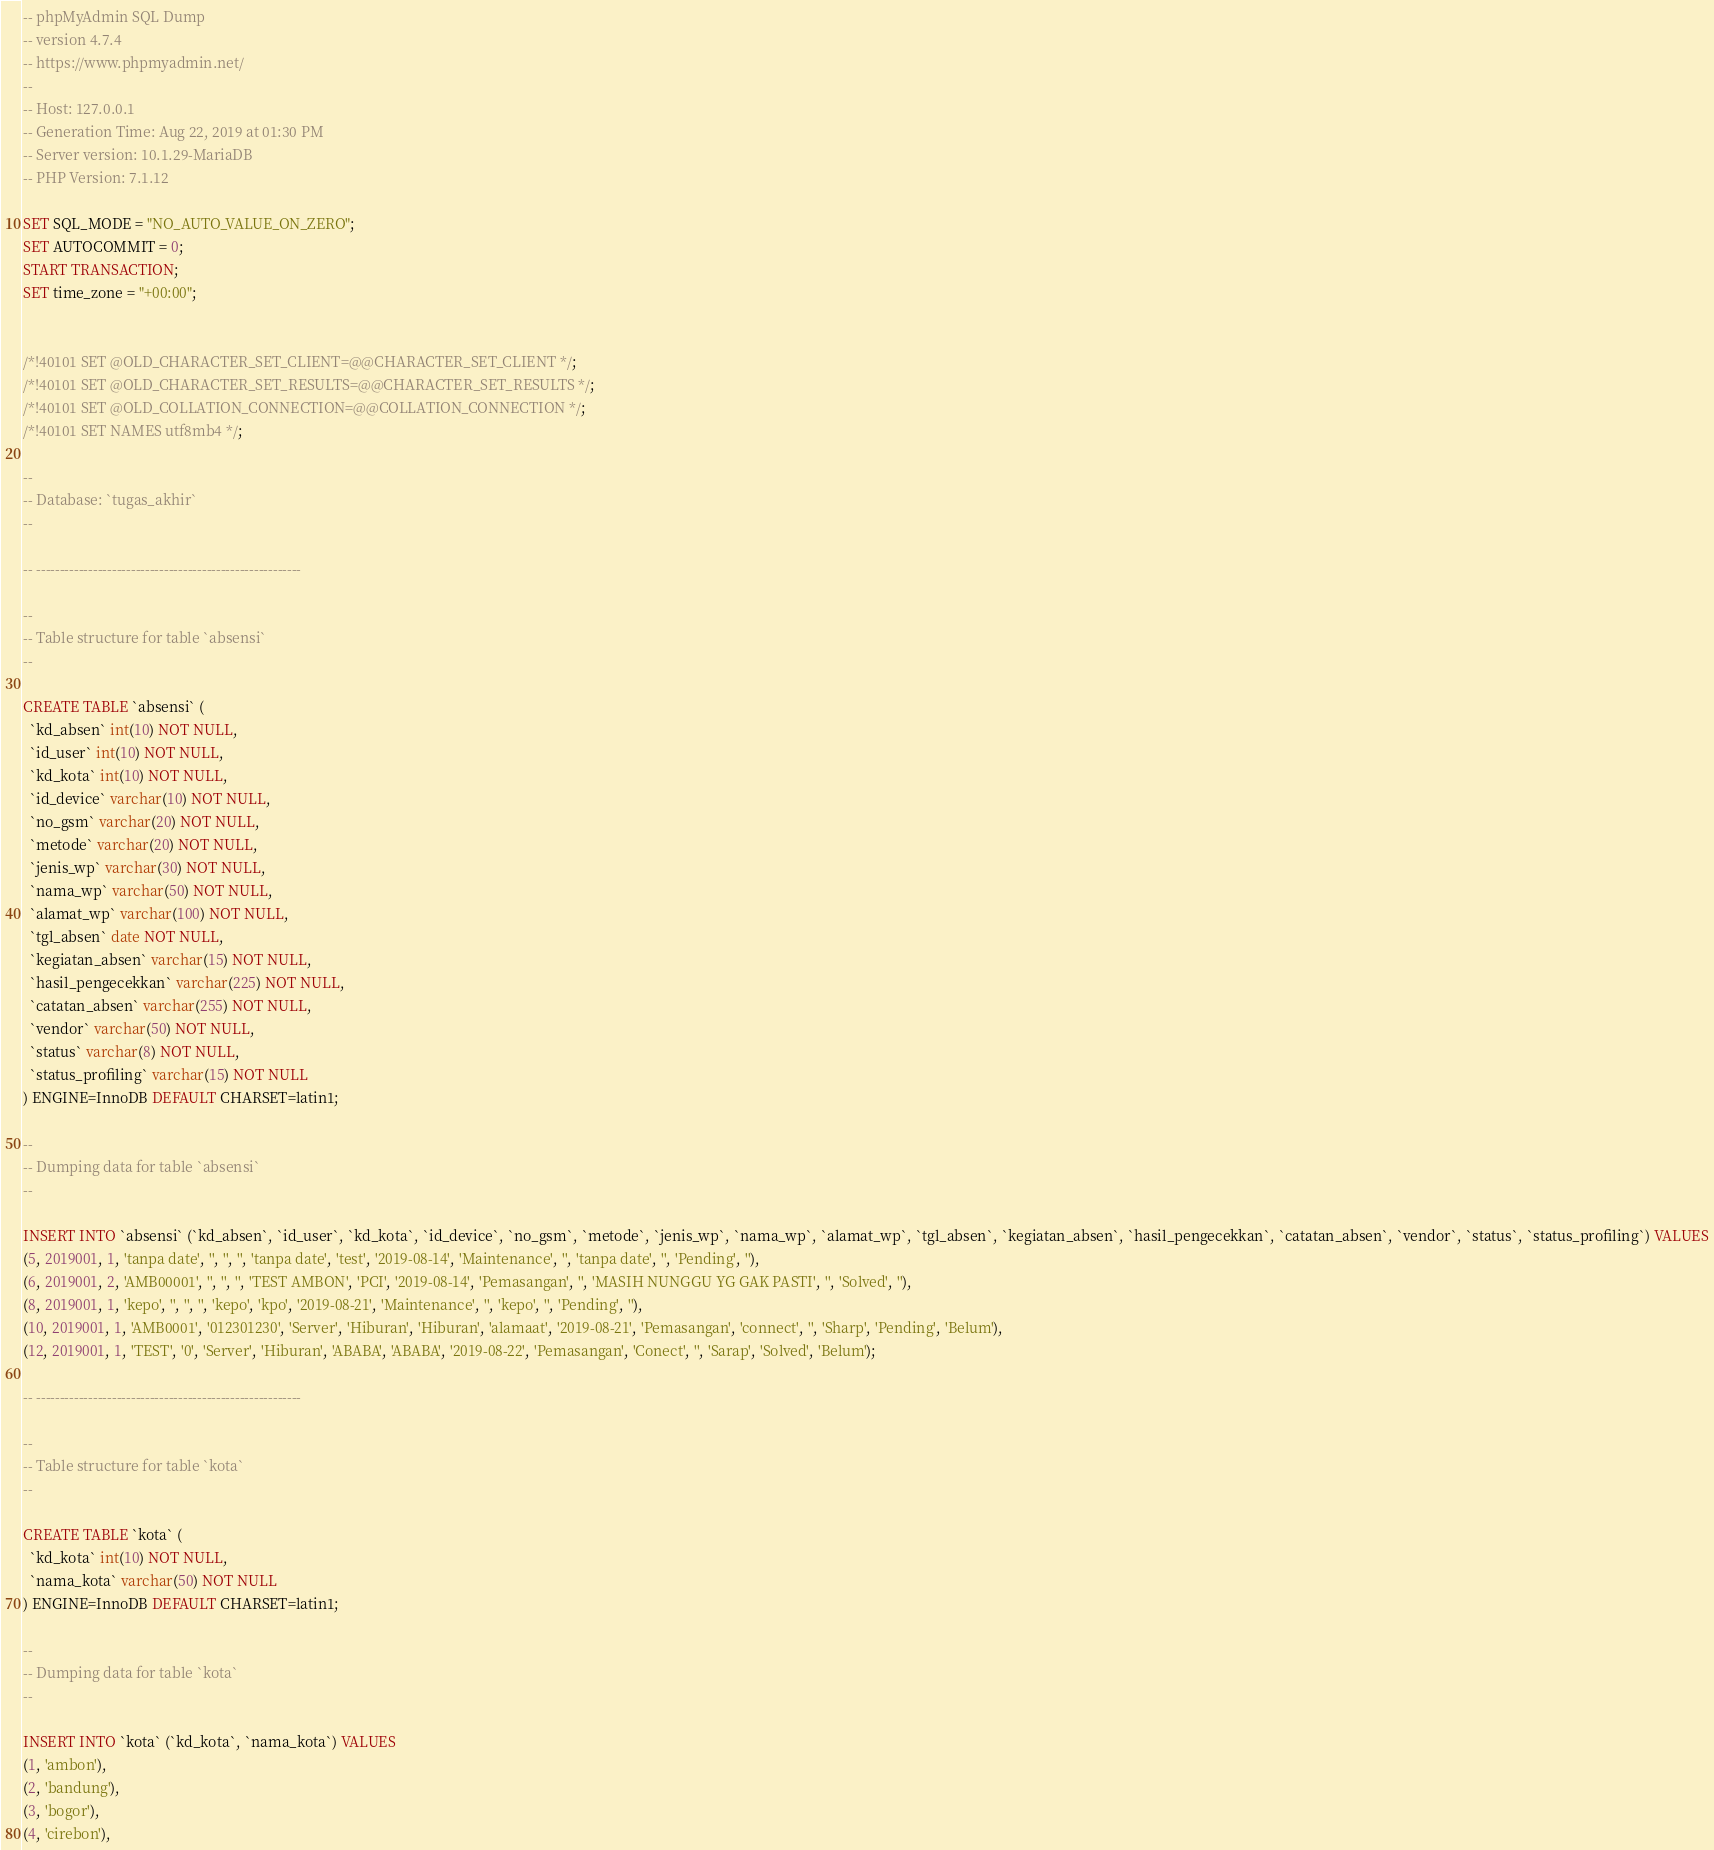<code> <loc_0><loc_0><loc_500><loc_500><_SQL_>-- phpMyAdmin SQL Dump
-- version 4.7.4
-- https://www.phpmyadmin.net/
--
-- Host: 127.0.0.1
-- Generation Time: Aug 22, 2019 at 01:30 PM
-- Server version: 10.1.29-MariaDB
-- PHP Version: 7.1.12

SET SQL_MODE = "NO_AUTO_VALUE_ON_ZERO";
SET AUTOCOMMIT = 0;
START TRANSACTION;
SET time_zone = "+00:00";


/*!40101 SET @OLD_CHARACTER_SET_CLIENT=@@CHARACTER_SET_CLIENT */;
/*!40101 SET @OLD_CHARACTER_SET_RESULTS=@@CHARACTER_SET_RESULTS */;
/*!40101 SET @OLD_COLLATION_CONNECTION=@@COLLATION_CONNECTION */;
/*!40101 SET NAMES utf8mb4 */;

--
-- Database: `tugas_akhir`
--

-- --------------------------------------------------------

--
-- Table structure for table `absensi`
--

CREATE TABLE `absensi` (
  `kd_absen` int(10) NOT NULL,
  `id_user` int(10) NOT NULL,
  `kd_kota` int(10) NOT NULL,
  `id_device` varchar(10) NOT NULL,
  `no_gsm` varchar(20) NOT NULL,
  `metode` varchar(20) NOT NULL,
  `jenis_wp` varchar(30) NOT NULL,
  `nama_wp` varchar(50) NOT NULL,
  `alamat_wp` varchar(100) NOT NULL,
  `tgl_absen` date NOT NULL,
  `kegiatan_absen` varchar(15) NOT NULL,
  `hasil_pengecekkan` varchar(225) NOT NULL,
  `catatan_absen` varchar(255) NOT NULL,
  `vendor` varchar(50) NOT NULL,
  `status` varchar(8) NOT NULL,
  `status_profiling` varchar(15) NOT NULL
) ENGINE=InnoDB DEFAULT CHARSET=latin1;

--
-- Dumping data for table `absensi`
--

INSERT INTO `absensi` (`kd_absen`, `id_user`, `kd_kota`, `id_device`, `no_gsm`, `metode`, `jenis_wp`, `nama_wp`, `alamat_wp`, `tgl_absen`, `kegiatan_absen`, `hasil_pengecekkan`, `catatan_absen`, `vendor`, `status`, `status_profiling`) VALUES
(5, 2019001, 1, 'tanpa date', '', '', '', 'tanpa date', 'test', '2019-08-14', 'Maintenance', '', 'tanpa date', '', 'Pending', ''),
(6, 2019001, 2, 'AMB00001', '', '', '', 'TEST AMBON', 'PCI', '2019-08-14', 'Pemasangan', '', 'MASIH NUNGGU YG GAK PASTI', '', 'Solved', ''),
(8, 2019001, 1, 'kepo', '', '', '', 'kepo', 'kpo', '2019-08-21', 'Maintenance', '', 'kepo', '', 'Pending', ''),
(10, 2019001, 1, 'AMB0001', '012301230', 'Server', 'Hiburan', 'Hiburan', 'alamaat', '2019-08-21', 'Pemasangan', 'connect', '', 'Sharp', 'Pending', 'Belum'),
(12, 2019001, 1, 'TEST', '0', 'Server', 'Hiburan', 'ABABA', 'ABABA', '2019-08-22', 'Pemasangan', 'Conect', '', 'Sarap', 'Solved', 'Belum');

-- --------------------------------------------------------

--
-- Table structure for table `kota`
--

CREATE TABLE `kota` (
  `kd_kota` int(10) NOT NULL,
  `nama_kota` varchar(50) NOT NULL
) ENGINE=InnoDB DEFAULT CHARSET=latin1;

--
-- Dumping data for table `kota`
--

INSERT INTO `kota` (`kd_kota`, `nama_kota`) VALUES
(1, 'ambon'),
(2, 'bandung'),
(3, 'bogor'),
(4, 'cirebon'),</code> 